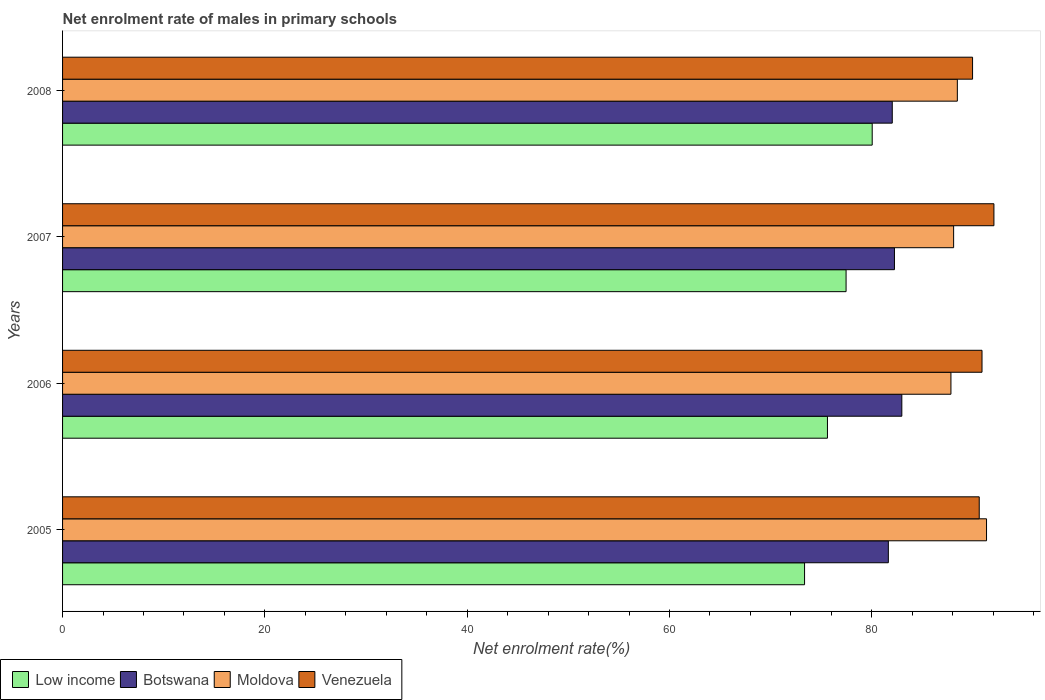How many groups of bars are there?
Your response must be concise. 4. Are the number of bars per tick equal to the number of legend labels?
Your answer should be compact. Yes. Are the number of bars on each tick of the Y-axis equal?
Your response must be concise. Yes. How many bars are there on the 2nd tick from the top?
Offer a terse response. 4. What is the label of the 3rd group of bars from the top?
Provide a succinct answer. 2006. In how many cases, is the number of bars for a given year not equal to the number of legend labels?
Your answer should be compact. 0. What is the net enrolment rate of males in primary schools in Moldova in 2007?
Your answer should be very brief. 88.09. Across all years, what is the maximum net enrolment rate of males in primary schools in Venezuela?
Ensure brevity in your answer.  92.07. Across all years, what is the minimum net enrolment rate of males in primary schools in Venezuela?
Your answer should be very brief. 89.96. What is the total net enrolment rate of males in primary schools in Low income in the graph?
Your answer should be very brief. 306.46. What is the difference between the net enrolment rate of males in primary schools in Venezuela in 2007 and that in 2008?
Provide a short and direct response. 2.11. What is the difference between the net enrolment rate of males in primary schools in Moldova in 2006 and the net enrolment rate of males in primary schools in Low income in 2008?
Provide a succinct answer. 7.78. What is the average net enrolment rate of males in primary schools in Venezuela per year?
Make the answer very short. 90.89. In the year 2005, what is the difference between the net enrolment rate of males in primary schools in Low income and net enrolment rate of males in primary schools in Moldova?
Ensure brevity in your answer.  -17.99. In how many years, is the net enrolment rate of males in primary schools in Venezuela greater than 88 %?
Offer a terse response. 4. What is the ratio of the net enrolment rate of males in primary schools in Moldova in 2005 to that in 2006?
Ensure brevity in your answer.  1.04. Is the difference between the net enrolment rate of males in primary schools in Low income in 2006 and 2007 greater than the difference between the net enrolment rate of males in primary schools in Moldova in 2006 and 2007?
Your answer should be compact. No. What is the difference between the highest and the second highest net enrolment rate of males in primary schools in Moldova?
Offer a very short reply. 2.89. What is the difference between the highest and the lowest net enrolment rate of males in primary schools in Low income?
Make the answer very short. 6.69. In how many years, is the net enrolment rate of males in primary schools in Venezuela greater than the average net enrolment rate of males in primary schools in Venezuela taken over all years?
Your answer should be very brief. 2. Is the sum of the net enrolment rate of males in primary schools in Low income in 2007 and 2008 greater than the maximum net enrolment rate of males in primary schools in Moldova across all years?
Make the answer very short. Yes. Is it the case that in every year, the sum of the net enrolment rate of males in primary schools in Moldova and net enrolment rate of males in primary schools in Low income is greater than the sum of net enrolment rate of males in primary schools in Botswana and net enrolment rate of males in primary schools in Venezuela?
Your answer should be very brief. No. What does the 3rd bar from the top in 2005 represents?
Offer a terse response. Botswana. What does the 3rd bar from the bottom in 2005 represents?
Make the answer very short. Moldova. What is the difference between two consecutive major ticks on the X-axis?
Your answer should be very brief. 20. Are the values on the major ticks of X-axis written in scientific E-notation?
Your response must be concise. No. How many legend labels are there?
Offer a very short reply. 4. What is the title of the graph?
Your answer should be very brief. Net enrolment rate of males in primary schools. What is the label or title of the X-axis?
Offer a very short reply. Net enrolment rate(%). What is the label or title of the Y-axis?
Offer a very short reply. Years. What is the Net enrolment rate(%) of Low income in 2005?
Offer a very short reply. 73.35. What is the Net enrolment rate(%) in Botswana in 2005?
Offer a terse response. 81.63. What is the Net enrolment rate(%) in Moldova in 2005?
Keep it short and to the point. 91.34. What is the Net enrolment rate(%) of Venezuela in 2005?
Provide a succinct answer. 90.62. What is the Net enrolment rate(%) of Low income in 2006?
Offer a very short reply. 75.61. What is the Net enrolment rate(%) in Botswana in 2006?
Offer a very short reply. 82.97. What is the Net enrolment rate(%) in Moldova in 2006?
Ensure brevity in your answer.  87.82. What is the Net enrolment rate(%) in Venezuela in 2006?
Keep it short and to the point. 90.89. What is the Net enrolment rate(%) in Low income in 2007?
Make the answer very short. 77.46. What is the Net enrolment rate(%) of Botswana in 2007?
Your response must be concise. 82.24. What is the Net enrolment rate(%) in Moldova in 2007?
Keep it short and to the point. 88.09. What is the Net enrolment rate(%) of Venezuela in 2007?
Ensure brevity in your answer.  92.07. What is the Net enrolment rate(%) of Low income in 2008?
Provide a short and direct response. 80.04. What is the Net enrolment rate(%) in Botswana in 2008?
Give a very brief answer. 82.02. What is the Net enrolment rate(%) in Moldova in 2008?
Give a very brief answer. 88.45. What is the Net enrolment rate(%) in Venezuela in 2008?
Your answer should be compact. 89.96. Across all years, what is the maximum Net enrolment rate(%) in Low income?
Your response must be concise. 80.04. Across all years, what is the maximum Net enrolment rate(%) in Botswana?
Your response must be concise. 82.97. Across all years, what is the maximum Net enrolment rate(%) of Moldova?
Make the answer very short. 91.34. Across all years, what is the maximum Net enrolment rate(%) of Venezuela?
Your answer should be compact. 92.07. Across all years, what is the minimum Net enrolment rate(%) of Low income?
Offer a very short reply. 73.35. Across all years, what is the minimum Net enrolment rate(%) in Botswana?
Offer a terse response. 81.63. Across all years, what is the minimum Net enrolment rate(%) of Moldova?
Your answer should be very brief. 87.82. Across all years, what is the minimum Net enrolment rate(%) of Venezuela?
Make the answer very short. 89.96. What is the total Net enrolment rate(%) in Low income in the graph?
Give a very brief answer. 306.46. What is the total Net enrolment rate(%) in Botswana in the graph?
Your response must be concise. 328.86. What is the total Net enrolment rate(%) of Moldova in the graph?
Provide a succinct answer. 355.71. What is the total Net enrolment rate(%) in Venezuela in the graph?
Give a very brief answer. 363.55. What is the difference between the Net enrolment rate(%) in Low income in 2005 and that in 2006?
Offer a very short reply. -2.26. What is the difference between the Net enrolment rate(%) in Botswana in 2005 and that in 2006?
Offer a very short reply. -1.33. What is the difference between the Net enrolment rate(%) of Moldova in 2005 and that in 2006?
Your answer should be very brief. 3.52. What is the difference between the Net enrolment rate(%) in Venezuela in 2005 and that in 2006?
Your answer should be compact. -0.28. What is the difference between the Net enrolment rate(%) of Low income in 2005 and that in 2007?
Give a very brief answer. -4.1. What is the difference between the Net enrolment rate(%) in Botswana in 2005 and that in 2007?
Make the answer very short. -0.6. What is the difference between the Net enrolment rate(%) in Moldova in 2005 and that in 2007?
Offer a terse response. 3.25. What is the difference between the Net enrolment rate(%) in Venezuela in 2005 and that in 2007?
Provide a succinct answer. -1.45. What is the difference between the Net enrolment rate(%) of Low income in 2005 and that in 2008?
Give a very brief answer. -6.69. What is the difference between the Net enrolment rate(%) of Botswana in 2005 and that in 2008?
Your answer should be very brief. -0.39. What is the difference between the Net enrolment rate(%) in Moldova in 2005 and that in 2008?
Your answer should be compact. 2.89. What is the difference between the Net enrolment rate(%) in Venezuela in 2005 and that in 2008?
Offer a terse response. 0.66. What is the difference between the Net enrolment rate(%) of Low income in 2006 and that in 2007?
Keep it short and to the point. -1.84. What is the difference between the Net enrolment rate(%) in Botswana in 2006 and that in 2007?
Your response must be concise. 0.73. What is the difference between the Net enrolment rate(%) of Moldova in 2006 and that in 2007?
Ensure brevity in your answer.  -0.27. What is the difference between the Net enrolment rate(%) in Venezuela in 2006 and that in 2007?
Make the answer very short. -1.18. What is the difference between the Net enrolment rate(%) of Low income in 2006 and that in 2008?
Provide a short and direct response. -4.42. What is the difference between the Net enrolment rate(%) in Botswana in 2006 and that in 2008?
Ensure brevity in your answer.  0.95. What is the difference between the Net enrolment rate(%) of Moldova in 2006 and that in 2008?
Provide a short and direct response. -0.63. What is the difference between the Net enrolment rate(%) of Venezuela in 2006 and that in 2008?
Ensure brevity in your answer.  0.93. What is the difference between the Net enrolment rate(%) in Low income in 2007 and that in 2008?
Ensure brevity in your answer.  -2.58. What is the difference between the Net enrolment rate(%) of Botswana in 2007 and that in 2008?
Your response must be concise. 0.22. What is the difference between the Net enrolment rate(%) of Moldova in 2007 and that in 2008?
Ensure brevity in your answer.  -0.37. What is the difference between the Net enrolment rate(%) of Venezuela in 2007 and that in 2008?
Your answer should be very brief. 2.11. What is the difference between the Net enrolment rate(%) in Low income in 2005 and the Net enrolment rate(%) in Botswana in 2006?
Offer a terse response. -9.62. What is the difference between the Net enrolment rate(%) in Low income in 2005 and the Net enrolment rate(%) in Moldova in 2006?
Your answer should be compact. -14.47. What is the difference between the Net enrolment rate(%) in Low income in 2005 and the Net enrolment rate(%) in Venezuela in 2006?
Provide a succinct answer. -17.54. What is the difference between the Net enrolment rate(%) in Botswana in 2005 and the Net enrolment rate(%) in Moldova in 2006?
Give a very brief answer. -6.19. What is the difference between the Net enrolment rate(%) of Botswana in 2005 and the Net enrolment rate(%) of Venezuela in 2006?
Provide a succinct answer. -9.26. What is the difference between the Net enrolment rate(%) in Moldova in 2005 and the Net enrolment rate(%) in Venezuela in 2006?
Give a very brief answer. 0.45. What is the difference between the Net enrolment rate(%) of Low income in 2005 and the Net enrolment rate(%) of Botswana in 2007?
Provide a succinct answer. -8.89. What is the difference between the Net enrolment rate(%) of Low income in 2005 and the Net enrolment rate(%) of Moldova in 2007?
Your answer should be very brief. -14.74. What is the difference between the Net enrolment rate(%) of Low income in 2005 and the Net enrolment rate(%) of Venezuela in 2007?
Provide a short and direct response. -18.72. What is the difference between the Net enrolment rate(%) in Botswana in 2005 and the Net enrolment rate(%) in Moldova in 2007?
Ensure brevity in your answer.  -6.45. What is the difference between the Net enrolment rate(%) in Botswana in 2005 and the Net enrolment rate(%) in Venezuela in 2007?
Ensure brevity in your answer.  -10.44. What is the difference between the Net enrolment rate(%) of Moldova in 2005 and the Net enrolment rate(%) of Venezuela in 2007?
Make the answer very short. -0.73. What is the difference between the Net enrolment rate(%) of Low income in 2005 and the Net enrolment rate(%) of Botswana in 2008?
Your answer should be compact. -8.67. What is the difference between the Net enrolment rate(%) of Low income in 2005 and the Net enrolment rate(%) of Moldova in 2008?
Provide a short and direct response. -15.1. What is the difference between the Net enrolment rate(%) of Low income in 2005 and the Net enrolment rate(%) of Venezuela in 2008?
Offer a terse response. -16.61. What is the difference between the Net enrolment rate(%) of Botswana in 2005 and the Net enrolment rate(%) of Moldova in 2008?
Give a very brief answer. -6.82. What is the difference between the Net enrolment rate(%) of Botswana in 2005 and the Net enrolment rate(%) of Venezuela in 2008?
Give a very brief answer. -8.33. What is the difference between the Net enrolment rate(%) of Moldova in 2005 and the Net enrolment rate(%) of Venezuela in 2008?
Your answer should be compact. 1.38. What is the difference between the Net enrolment rate(%) of Low income in 2006 and the Net enrolment rate(%) of Botswana in 2007?
Your answer should be compact. -6.62. What is the difference between the Net enrolment rate(%) in Low income in 2006 and the Net enrolment rate(%) in Moldova in 2007?
Offer a very short reply. -12.47. What is the difference between the Net enrolment rate(%) of Low income in 2006 and the Net enrolment rate(%) of Venezuela in 2007?
Provide a short and direct response. -16.46. What is the difference between the Net enrolment rate(%) of Botswana in 2006 and the Net enrolment rate(%) of Moldova in 2007?
Offer a terse response. -5.12. What is the difference between the Net enrolment rate(%) of Botswana in 2006 and the Net enrolment rate(%) of Venezuela in 2007?
Offer a very short reply. -9.1. What is the difference between the Net enrolment rate(%) in Moldova in 2006 and the Net enrolment rate(%) in Venezuela in 2007?
Give a very brief answer. -4.25. What is the difference between the Net enrolment rate(%) in Low income in 2006 and the Net enrolment rate(%) in Botswana in 2008?
Give a very brief answer. -6.41. What is the difference between the Net enrolment rate(%) in Low income in 2006 and the Net enrolment rate(%) in Moldova in 2008?
Provide a succinct answer. -12.84. What is the difference between the Net enrolment rate(%) in Low income in 2006 and the Net enrolment rate(%) in Venezuela in 2008?
Make the answer very short. -14.35. What is the difference between the Net enrolment rate(%) in Botswana in 2006 and the Net enrolment rate(%) in Moldova in 2008?
Offer a very short reply. -5.49. What is the difference between the Net enrolment rate(%) in Botswana in 2006 and the Net enrolment rate(%) in Venezuela in 2008?
Your answer should be very brief. -6.99. What is the difference between the Net enrolment rate(%) of Moldova in 2006 and the Net enrolment rate(%) of Venezuela in 2008?
Provide a short and direct response. -2.14. What is the difference between the Net enrolment rate(%) of Low income in 2007 and the Net enrolment rate(%) of Botswana in 2008?
Your answer should be very brief. -4.57. What is the difference between the Net enrolment rate(%) of Low income in 2007 and the Net enrolment rate(%) of Moldova in 2008?
Keep it short and to the point. -11. What is the difference between the Net enrolment rate(%) in Low income in 2007 and the Net enrolment rate(%) in Venezuela in 2008?
Your response must be concise. -12.51. What is the difference between the Net enrolment rate(%) in Botswana in 2007 and the Net enrolment rate(%) in Moldova in 2008?
Offer a terse response. -6.22. What is the difference between the Net enrolment rate(%) of Botswana in 2007 and the Net enrolment rate(%) of Venezuela in 2008?
Your answer should be compact. -7.72. What is the difference between the Net enrolment rate(%) in Moldova in 2007 and the Net enrolment rate(%) in Venezuela in 2008?
Your answer should be very brief. -1.87. What is the average Net enrolment rate(%) of Low income per year?
Keep it short and to the point. 76.62. What is the average Net enrolment rate(%) in Botswana per year?
Your answer should be compact. 82.22. What is the average Net enrolment rate(%) in Moldova per year?
Your answer should be very brief. 88.93. What is the average Net enrolment rate(%) of Venezuela per year?
Your answer should be compact. 90.89. In the year 2005, what is the difference between the Net enrolment rate(%) of Low income and Net enrolment rate(%) of Botswana?
Your answer should be very brief. -8.28. In the year 2005, what is the difference between the Net enrolment rate(%) of Low income and Net enrolment rate(%) of Moldova?
Provide a short and direct response. -17.99. In the year 2005, what is the difference between the Net enrolment rate(%) in Low income and Net enrolment rate(%) in Venezuela?
Give a very brief answer. -17.27. In the year 2005, what is the difference between the Net enrolment rate(%) of Botswana and Net enrolment rate(%) of Moldova?
Offer a terse response. -9.71. In the year 2005, what is the difference between the Net enrolment rate(%) in Botswana and Net enrolment rate(%) in Venezuela?
Offer a terse response. -8.98. In the year 2005, what is the difference between the Net enrolment rate(%) of Moldova and Net enrolment rate(%) of Venezuela?
Ensure brevity in your answer.  0.72. In the year 2006, what is the difference between the Net enrolment rate(%) in Low income and Net enrolment rate(%) in Botswana?
Ensure brevity in your answer.  -7.35. In the year 2006, what is the difference between the Net enrolment rate(%) of Low income and Net enrolment rate(%) of Moldova?
Your answer should be very brief. -12.21. In the year 2006, what is the difference between the Net enrolment rate(%) of Low income and Net enrolment rate(%) of Venezuela?
Offer a terse response. -15.28. In the year 2006, what is the difference between the Net enrolment rate(%) of Botswana and Net enrolment rate(%) of Moldova?
Your answer should be compact. -4.85. In the year 2006, what is the difference between the Net enrolment rate(%) in Botswana and Net enrolment rate(%) in Venezuela?
Ensure brevity in your answer.  -7.93. In the year 2006, what is the difference between the Net enrolment rate(%) of Moldova and Net enrolment rate(%) of Venezuela?
Keep it short and to the point. -3.07. In the year 2007, what is the difference between the Net enrolment rate(%) in Low income and Net enrolment rate(%) in Botswana?
Your response must be concise. -4.78. In the year 2007, what is the difference between the Net enrolment rate(%) in Low income and Net enrolment rate(%) in Moldova?
Give a very brief answer. -10.63. In the year 2007, what is the difference between the Net enrolment rate(%) in Low income and Net enrolment rate(%) in Venezuela?
Offer a very short reply. -14.62. In the year 2007, what is the difference between the Net enrolment rate(%) in Botswana and Net enrolment rate(%) in Moldova?
Offer a very short reply. -5.85. In the year 2007, what is the difference between the Net enrolment rate(%) of Botswana and Net enrolment rate(%) of Venezuela?
Ensure brevity in your answer.  -9.83. In the year 2007, what is the difference between the Net enrolment rate(%) in Moldova and Net enrolment rate(%) in Venezuela?
Give a very brief answer. -3.98. In the year 2008, what is the difference between the Net enrolment rate(%) in Low income and Net enrolment rate(%) in Botswana?
Your response must be concise. -1.98. In the year 2008, what is the difference between the Net enrolment rate(%) in Low income and Net enrolment rate(%) in Moldova?
Keep it short and to the point. -8.42. In the year 2008, what is the difference between the Net enrolment rate(%) of Low income and Net enrolment rate(%) of Venezuela?
Your answer should be very brief. -9.92. In the year 2008, what is the difference between the Net enrolment rate(%) of Botswana and Net enrolment rate(%) of Moldova?
Offer a very short reply. -6.43. In the year 2008, what is the difference between the Net enrolment rate(%) in Botswana and Net enrolment rate(%) in Venezuela?
Provide a short and direct response. -7.94. In the year 2008, what is the difference between the Net enrolment rate(%) in Moldova and Net enrolment rate(%) in Venezuela?
Provide a succinct answer. -1.51. What is the ratio of the Net enrolment rate(%) in Low income in 2005 to that in 2006?
Keep it short and to the point. 0.97. What is the ratio of the Net enrolment rate(%) of Botswana in 2005 to that in 2006?
Ensure brevity in your answer.  0.98. What is the ratio of the Net enrolment rate(%) of Moldova in 2005 to that in 2006?
Ensure brevity in your answer.  1.04. What is the ratio of the Net enrolment rate(%) in Venezuela in 2005 to that in 2006?
Your response must be concise. 1. What is the ratio of the Net enrolment rate(%) in Low income in 2005 to that in 2007?
Provide a short and direct response. 0.95. What is the ratio of the Net enrolment rate(%) of Moldova in 2005 to that in 2007?
Make the answer very short. 1.04. What is the ratio of the Net enrolment rate(%) in Venezuela in 2005 to that in 2007?
Your answer should be compact. 0.98. What is the ratio of the Net enrolment rate(%) in Low income in 2005 to that in 2008?
Keep it short and to the point. 0.92. What is the ratio of the Net enrolment rate(%) of Moldova in 2005 to that in 2008?
Offer a terse response. 1.03. What is the ratio of the Net enrolment rate(%) in Venezuela in 2005 to that in 2008?
Make the answer very short. 1.01. What is the ratio of the Net enrolment rate(%) in Low income in 2006 to that in 2007?
Your answer should be very brief. 0.98. What is the ratio of the Net enrolment rate(%) in Botswana in 2006 to that in 2007?
Your answer should be compact. 1.01. What is the ratio of the Net enrolment rate(%) in Moldova in 2006 to that in 2007?
Provide a short and direct response. 1. What is the ratio of the Net enrolment rate(%) in Venezuela in 2006 to that in 2007?
Your answer should be very brief. 0.99. What is the ratio of the Net enrolment rate(%) of Low income in 2006 to that in 2008?
Offer a very short reply. 0.94. What is the ratio of the Net enrolment rate(%) of Botswana in 2006 to that in 2008?
Make the answer very short. 1.01. What is the ratio of the Net enrolment rate(%) in Moldova in 2006 to that in 2008?
Offer a terse response. 0.99. What is the ratio of the Net enrolment rate(%) of Venezuela in 2006 to that in 2008?
Your answer should be compact. 1.01. What is the ratio of the Net enrolment rate(%) in Low income in 2007 to that in 2008?
Provide a succinct answer. 0.97. What is the ratio of the Net enrolment rate(%) in Venezuela in 2007 to that in 2008?
Provide a short and direct response. 1.02. What is the difference between the highest and the second highest Net enrolment rate(%) of Low income?
Provide a short and direct response. 2.58. What is the difference between the highest and the second highest Net enrolment rate(%) of Botswana?
Ensure brevity in your answer.  0.73. What is the difference between the highest and the second highest Net enrolment rate(%) in Moldova?
Your response must be concise. 2.89. What is the difference between the highest and the second highest Net enrolment rate(%) of Venezuela?
Keep it short and to the point. 1.18. What is the difference between the highest and the lowest Net enrolment rate(%) of Low income?
Give a very brief answer. 6.69. What is the difference between the highest and the lowest Net enrolment rate(%) in Botswana?
Your answer should be very brief. 1.33. What is the difference between the highest and the lowest Net enrolment rate(%) of Moldova?
Offer a terse response. 3.52. What is the difference between the highest and the lowest Net enrolment rate(%) of Venezuela?
Offer a very short reply. 2.11. 